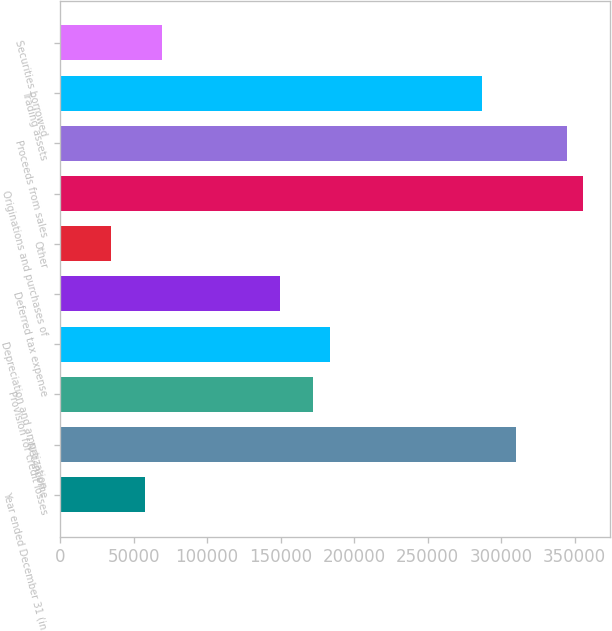Convert chart. <chart><loc_0><loc_0><loc_500><loc_500><bar_chart><fcel>Year ended December 31 (in<fcel>Net income<fcel>Provision for credit losses<fcel>Depreciation and amortization<fcel>Deferred tax expense<fcel>Other<fcel>Originations and purchases of<fcel>Proceeds from sales<fcel>Trading assets<fcel>Securities borrowed<nl><fcel>57542<fcel>310133<fcel>172356<fcel>183837<fcel>149393<fcel>34579.2<fcel>356058<fcel>344577<fcel>287170<fcel>69023.4<nl></chart> 